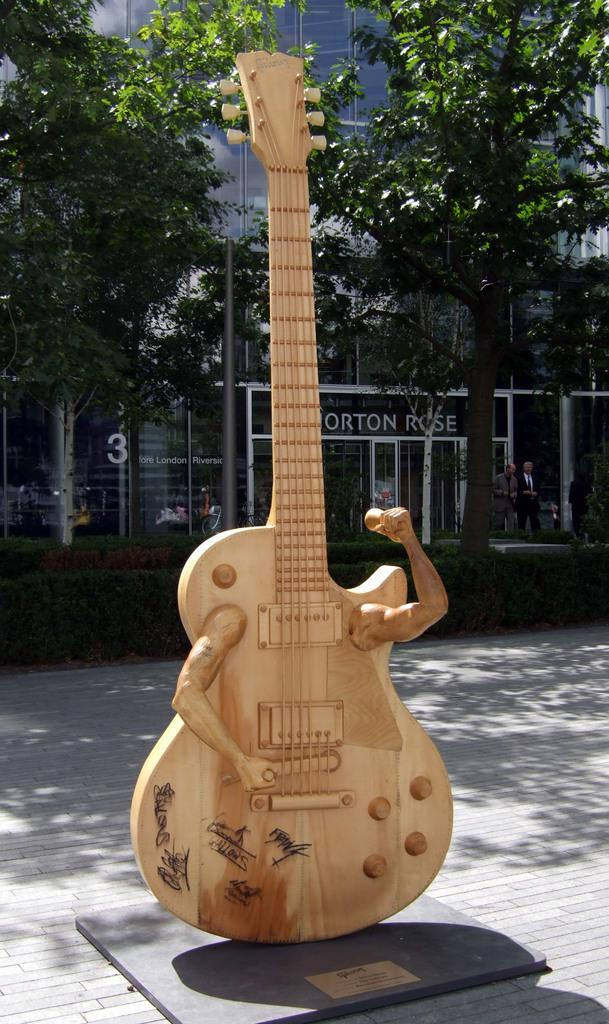What type of instrument is in the image? There is a wooden guitar in the image. Where is the wooden guitar located? The wooden guitar is placed on the street. What is unusual about the wooden guitar in the image? The wooden guitar has hands coming out of it. What can be seen in the background of the image? There are buildings and trees in the background of the image. What type of brass instrument is being played by the wall in the image? There is no brass instrument or wall present in the image. 